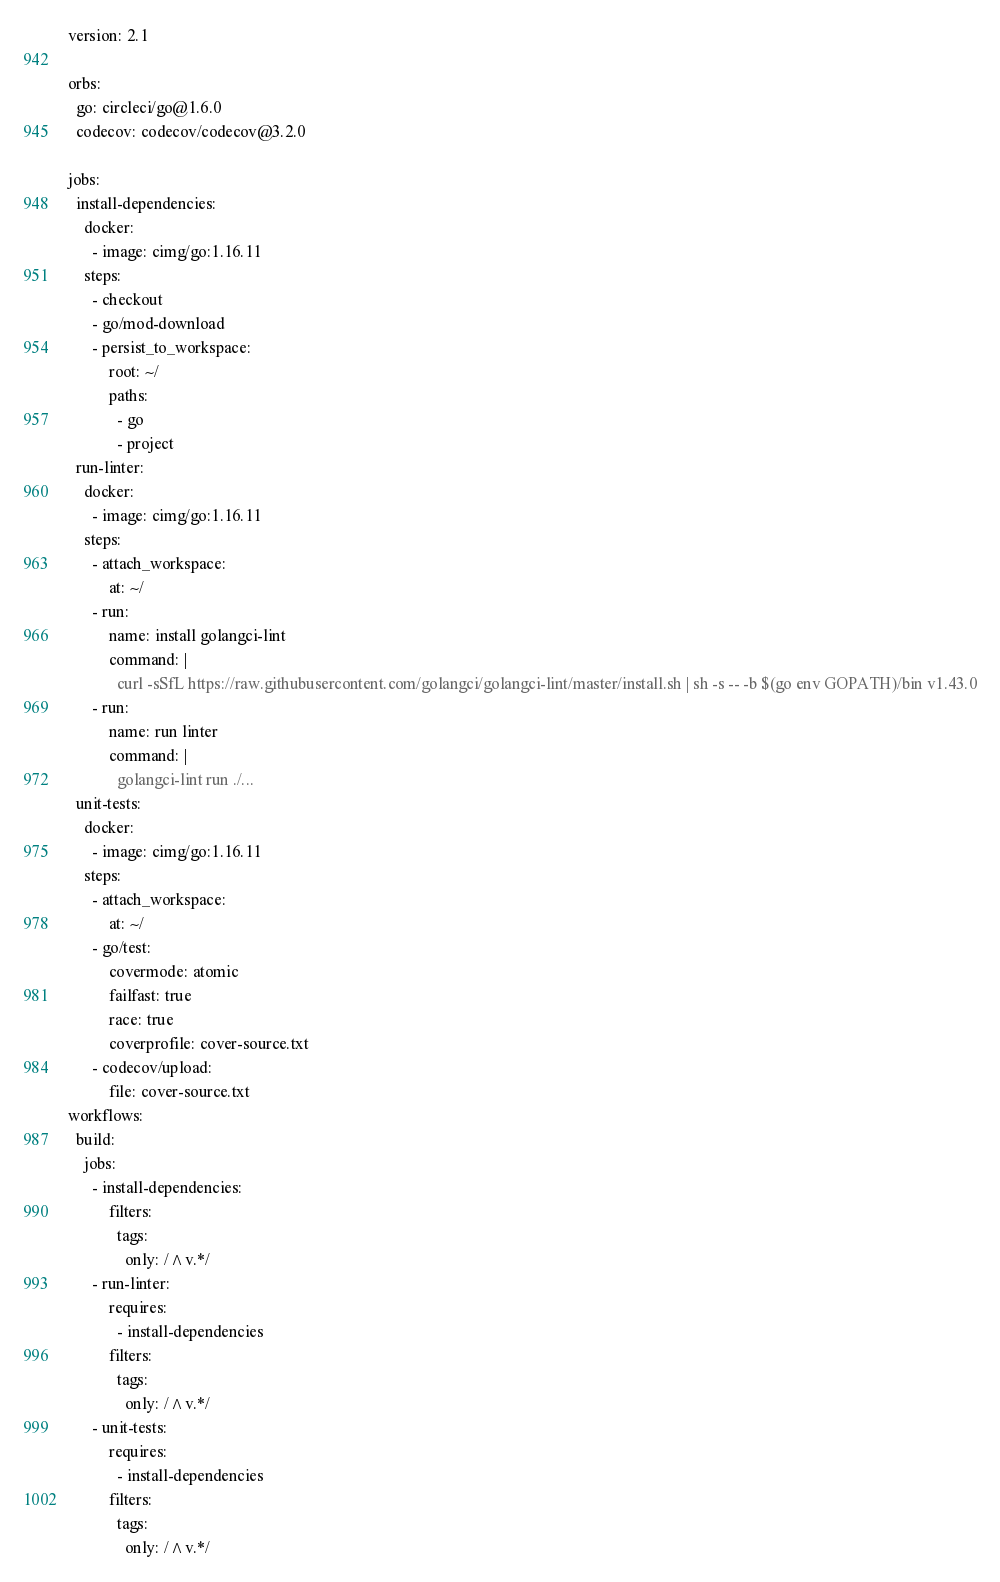<code> <loc_0><loc_0><loc_500><loc_500><_YAML_>version: 2.1

orbs:
  go: circleci/go@1.6.0
  codecov: codecov/codecov@3.2.0

jobs:
  install-dependencies:
    docker:
      - image: cimg/go:1.16.11
    steps:
      - checkout
      - go/mod-download
      - persist_to_workspace:
          root: ~/
          paths:
            - go
            - project
  run-linter:
    docker:
      - image: cimg/go:1.16.11
    steps:
      - attach_workspace:
          at: ~/
      - run:
          name: install golangci-lint
          command: |
            curl -sSfL https://raw.githubusercontent.com/golangci/golangci-lint/master/install.sh | sh -s -- -b $(go env GOPATH)/bin v1.43.0
      - run:
          name: run linter
          command: |
            golangci-lint run ./...
  unit-tests:
    docker:
      - image: cimg/go:1.16.11
    steps:
      - attach_workspace:
          at: ~/
      - go/test:
          covermode: atomic
          failfast: true
          race: true
          coverprofile: cover-source.txt
      - codecov/upload:
          file: cover-source.txt
workflows:
  build:
    jobs:
      - install-dependencies:
          filters:
            tags:
              only: /^v.*/
      - run-linter:
          requires:
            - install-dependencies
          filters:
            tags:
              only: /^v.*/
      - unit-tests:
          requires:
            - install-dependencies
          filters:
            tags:
              only: /^v.*/</code> 